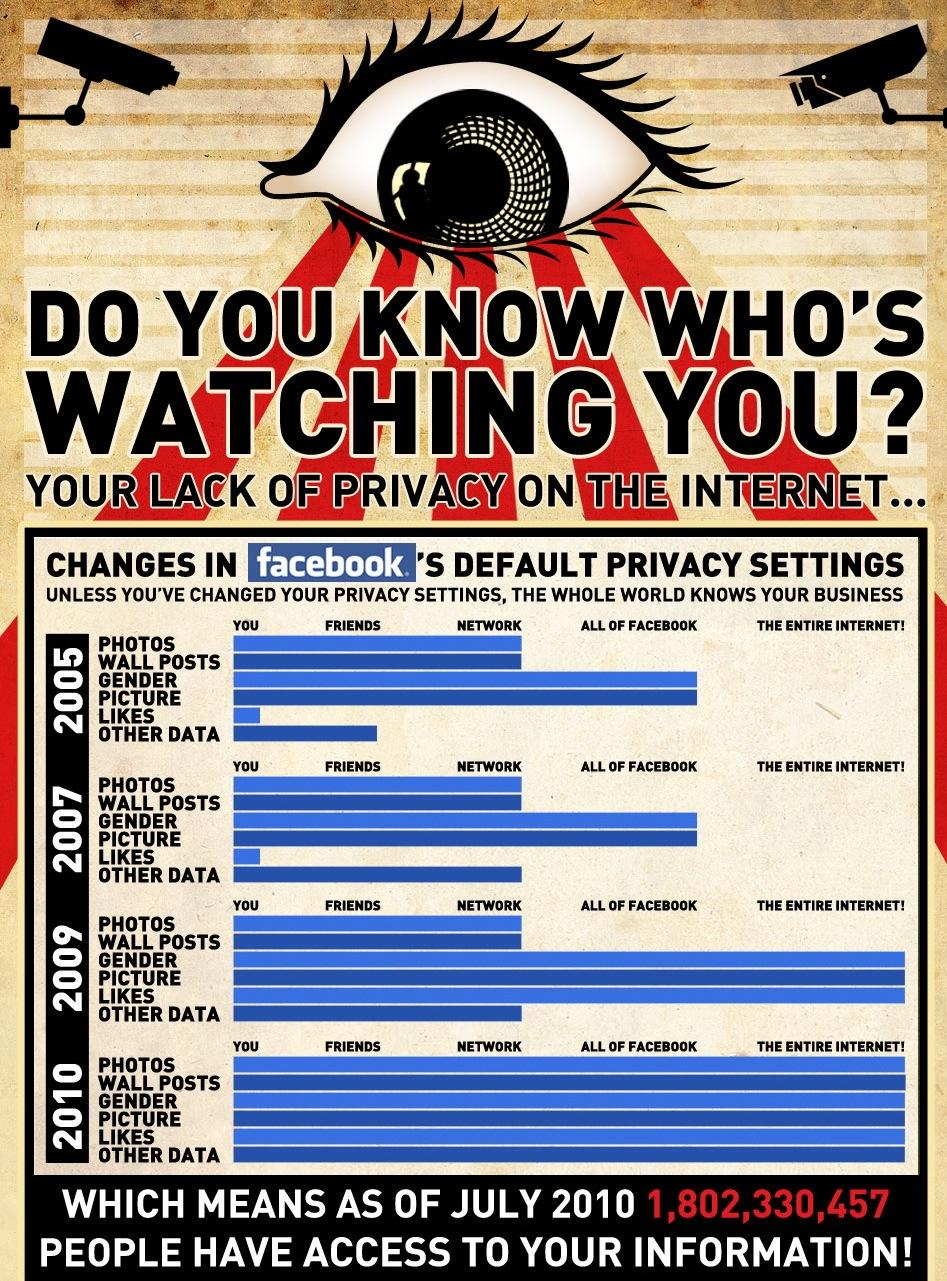Draw attention to some important aspects in this diagram. Facebook's third level privacy setting is "Network. Facebook's second level privacy setting for friends is a way to control who can see your posts and information. In the year 2005, anyone with a Facebook account could view a feature that was available on the platform. This feature was not limited to users' gender or profile picture. In 2007, the default privacy setting for Facebook features related to gender and profile pictures was "All Of Facebook. In 2009, Facebook made certain features, including photos and wall posts, available to the network for use. 